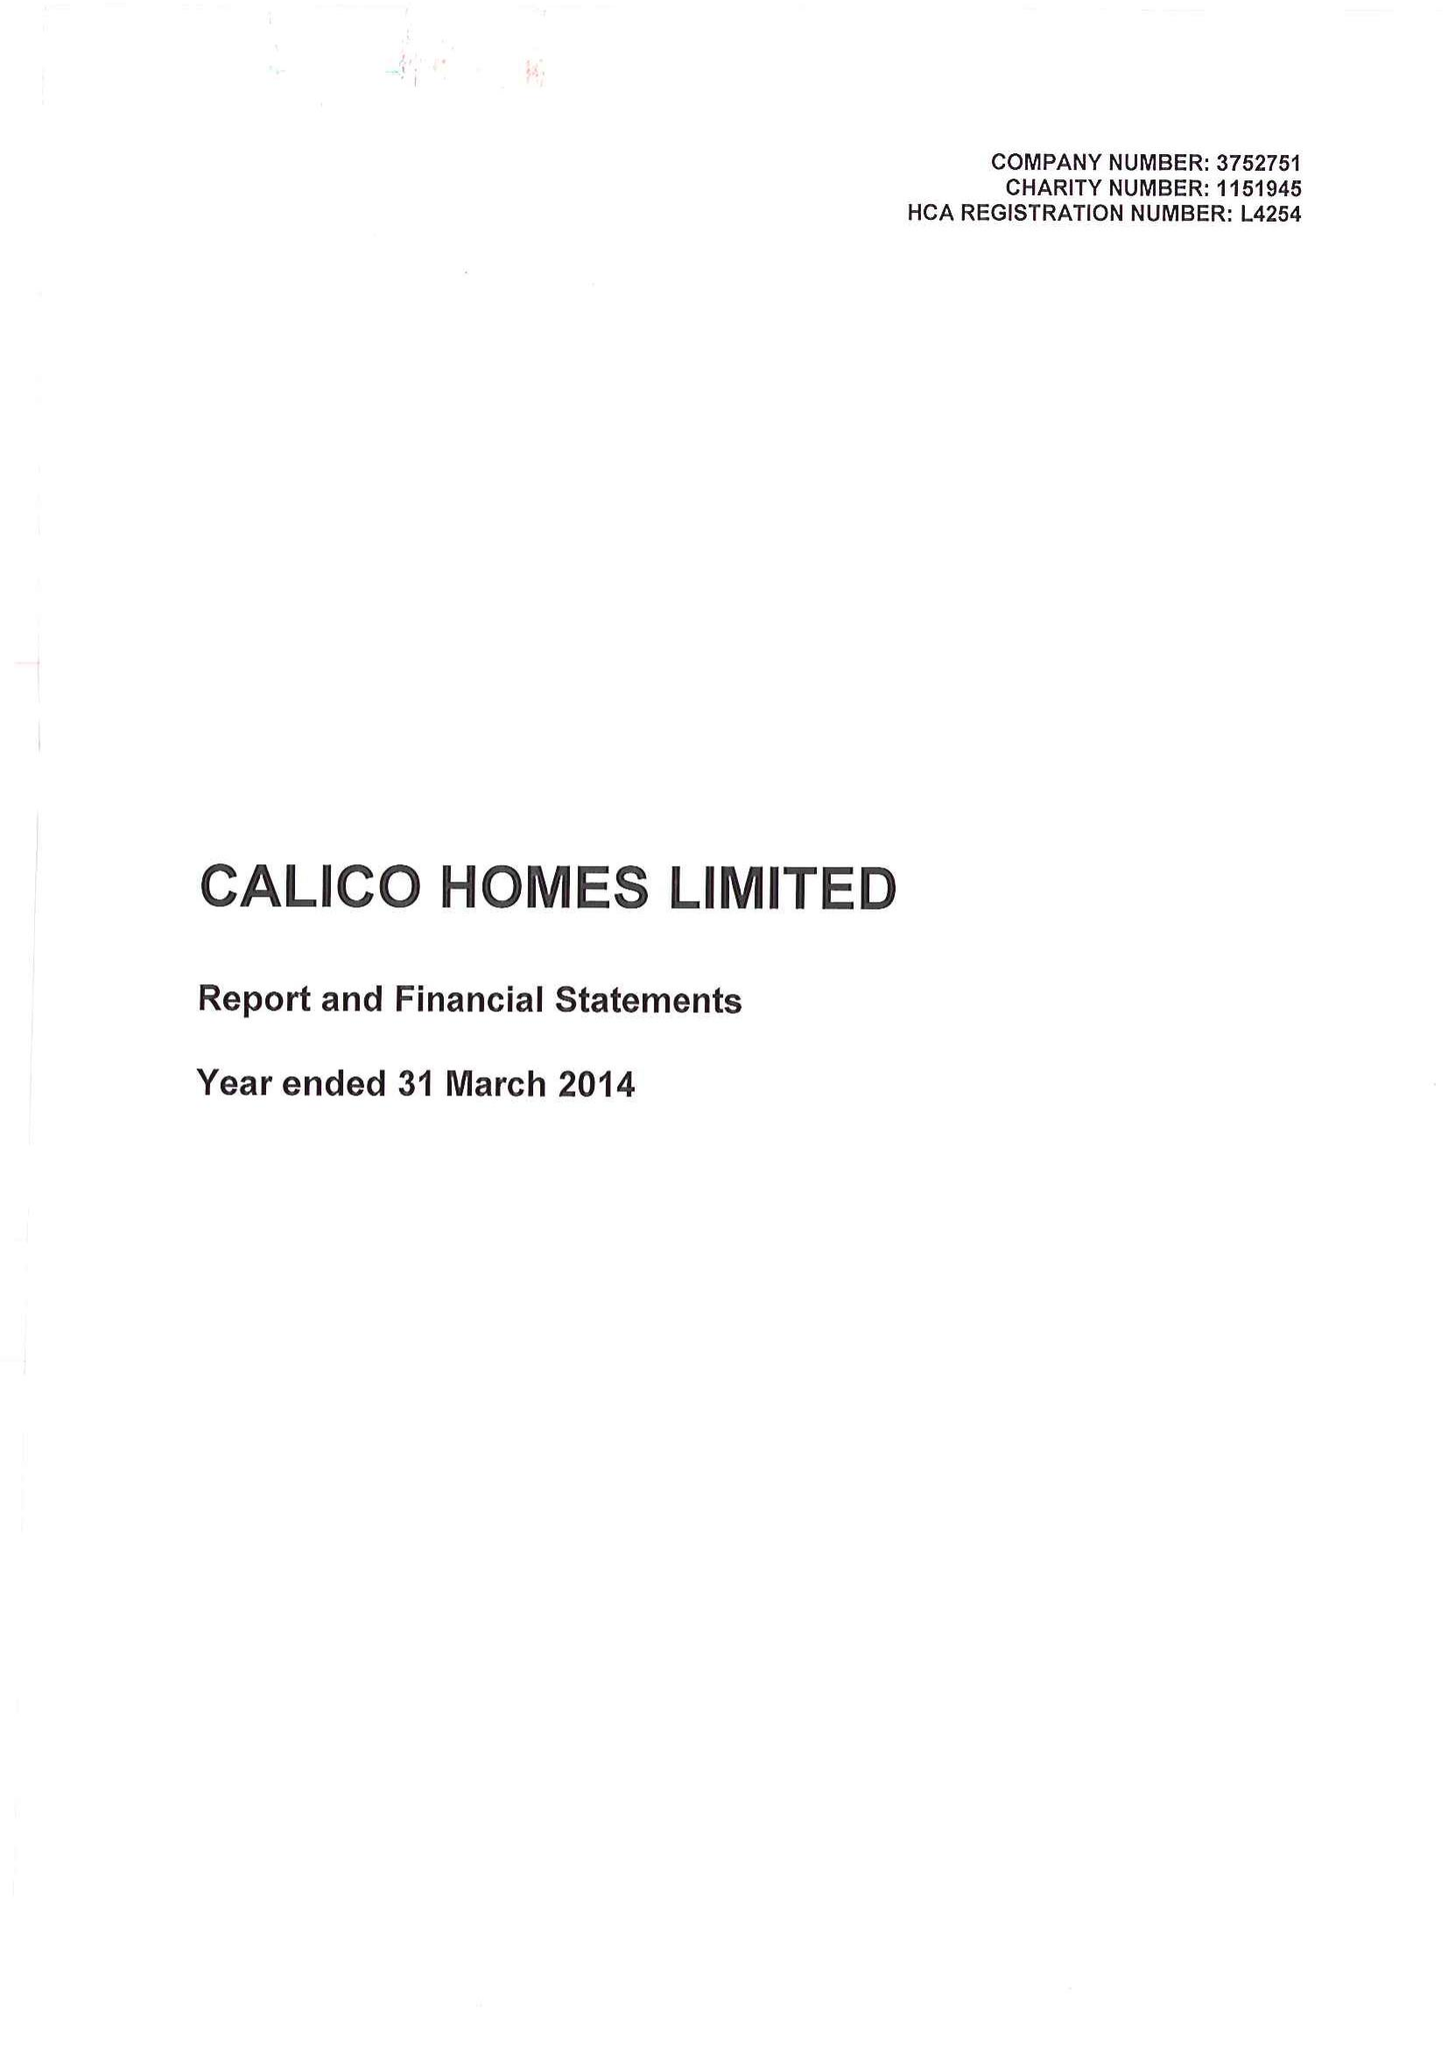What is the value for the income_annually_in_british_pounds?
Answer the question using a single word or phrase. 20988000.00 